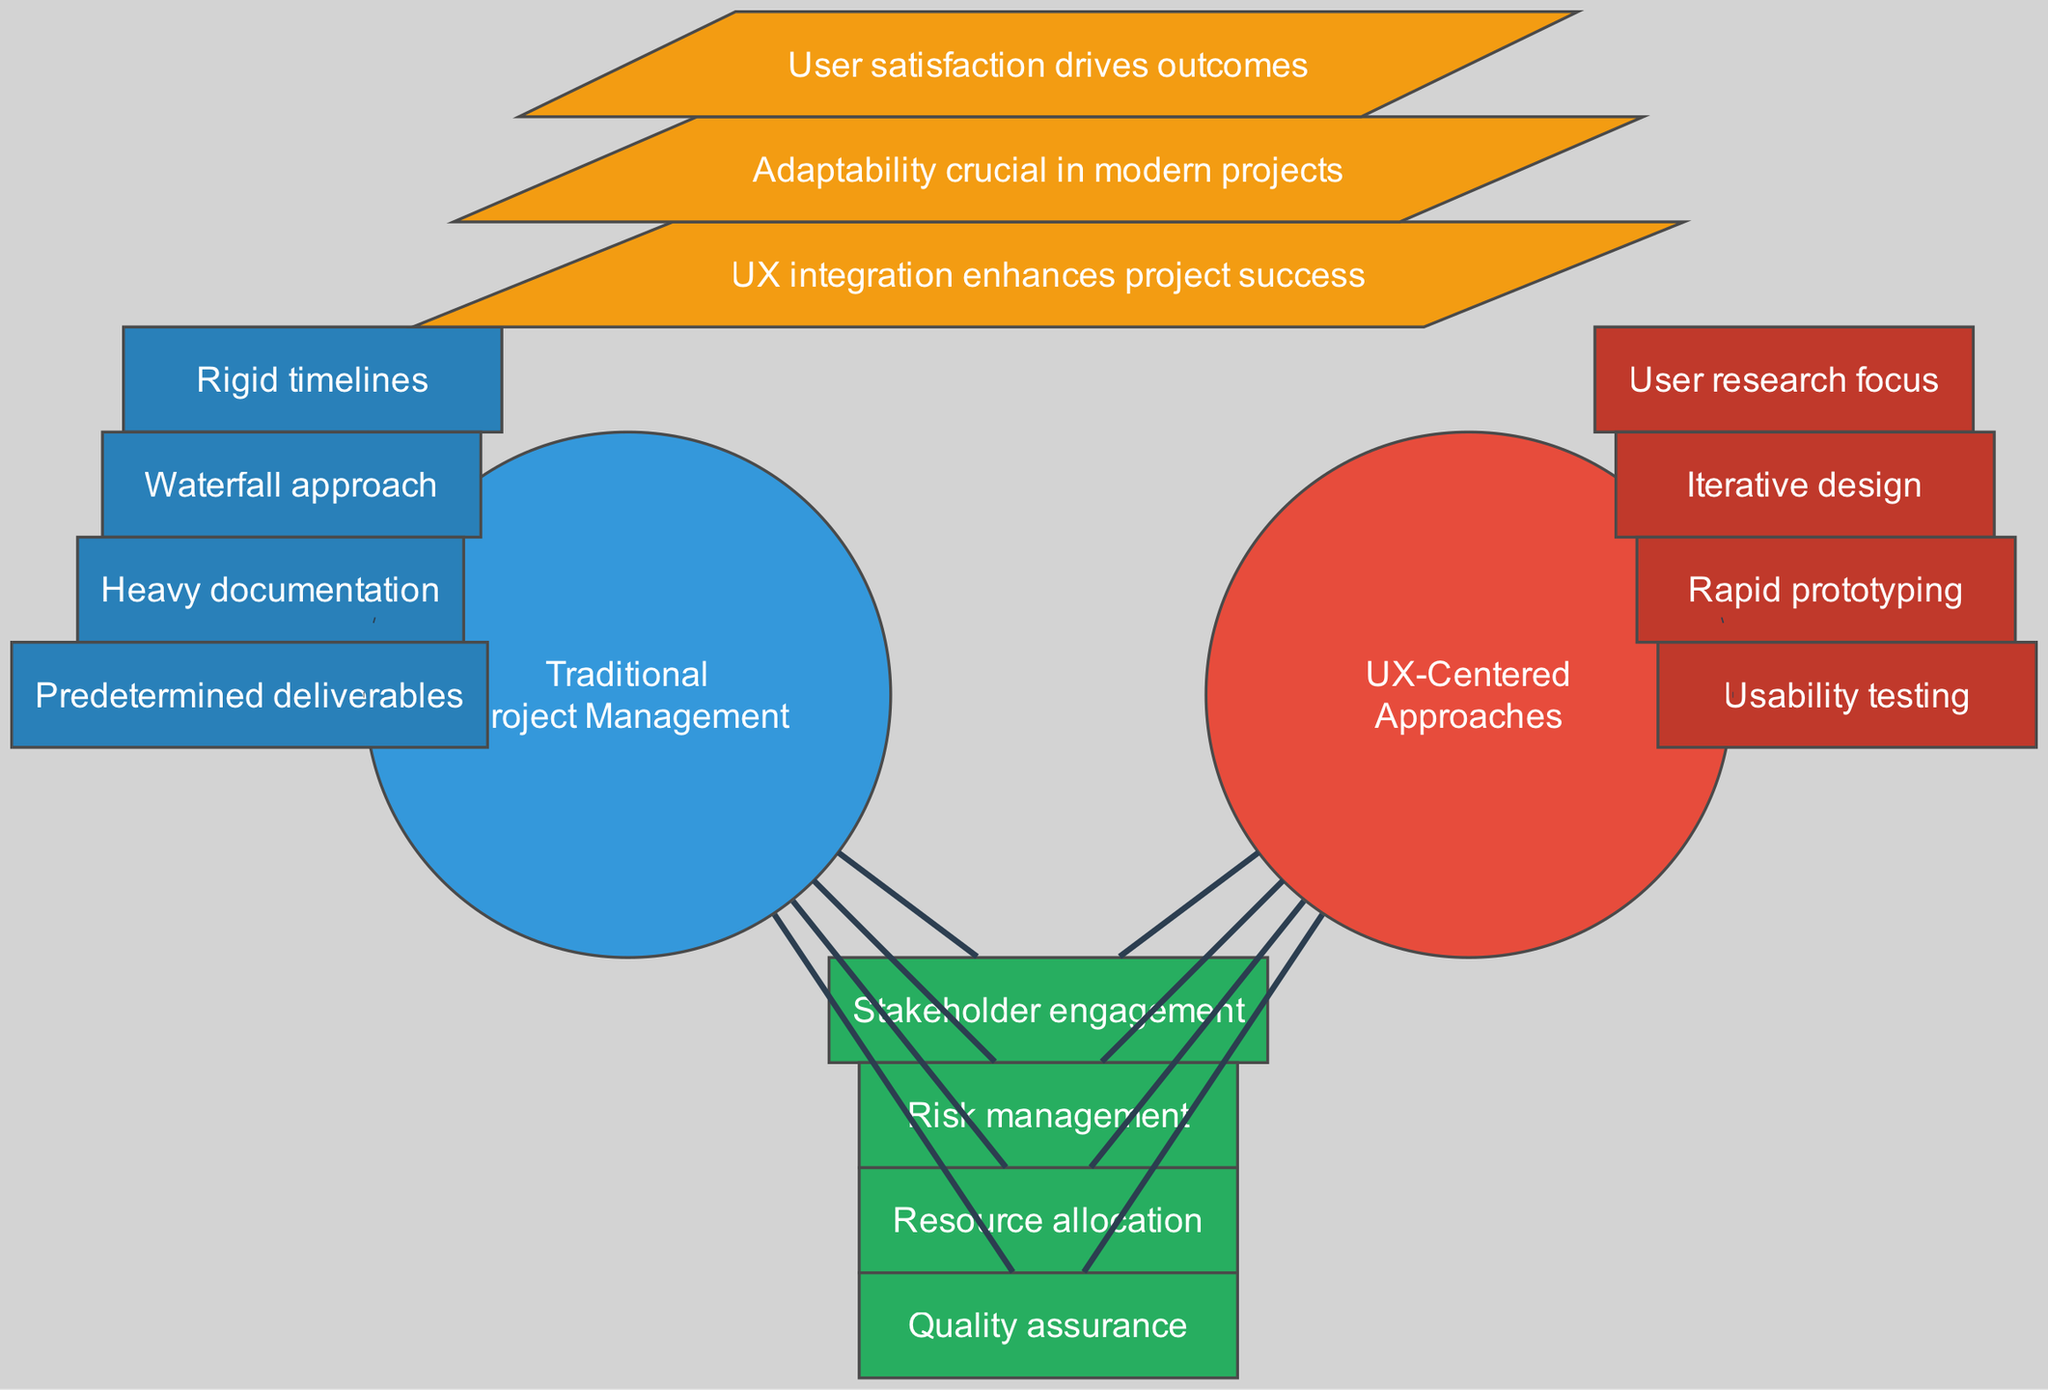What are the unique features of Traditional Project Management? The unique features are seen in the section dedicated to Traditional Project Management which lists "Rigid timelines", "Waterfall approach", "Heavy documentation", and "Predetermined deliverables".
Answer: Rigid timelines, Waterfall approach, Heavy documentation, Predetermined deliverables How many unique features are listed for UX-Centered Approaches? In the diagram's section for UX-Centered Approaches, there are four unique features mentioned. This can be counted directly from the nodes that display the unique features.
Answer: 4 What do stakeholder engagement, risk management, resource allocation, and quality assurance have in common? These are all features found in the overlapping section of the diagram, indicating shared aspects between Traditional Project Management and UX-Centered Approaches.
Answer: They are shared features Which insight emphasizes user satisfaction? Among the key insights displayed in the diagram, the insight that states "User satisfaction drives outcomes" directly highlights the importance of user satisfaction.
Answer: User satisfaction drives outcomes What is the key insight regarding the adaptability of modern projects? The key insight mentioning adaptability says "Adaptability crucial in modern projects", identified in the section depicting key insights in the diagram.
Answer: Adaptability crucial in modern projects How many features are exclusively found in Traditional Project Management? The diagram shows four unique features specific to Traditional Project Management, which can be counted from that section of the diagram.
Answer: 4 What color represents the overlap between both methodologies? In the diagram, the color green is used to represent the overlapping features, indicating commonalities between the two approaches.
Answer: Green Which methodology focuses primarily on user research? From the section uniquely identifying UX-Centered Approaches, it is clear that their primary focus is on "User research focus".
Answer: UX-Centered Approaches 